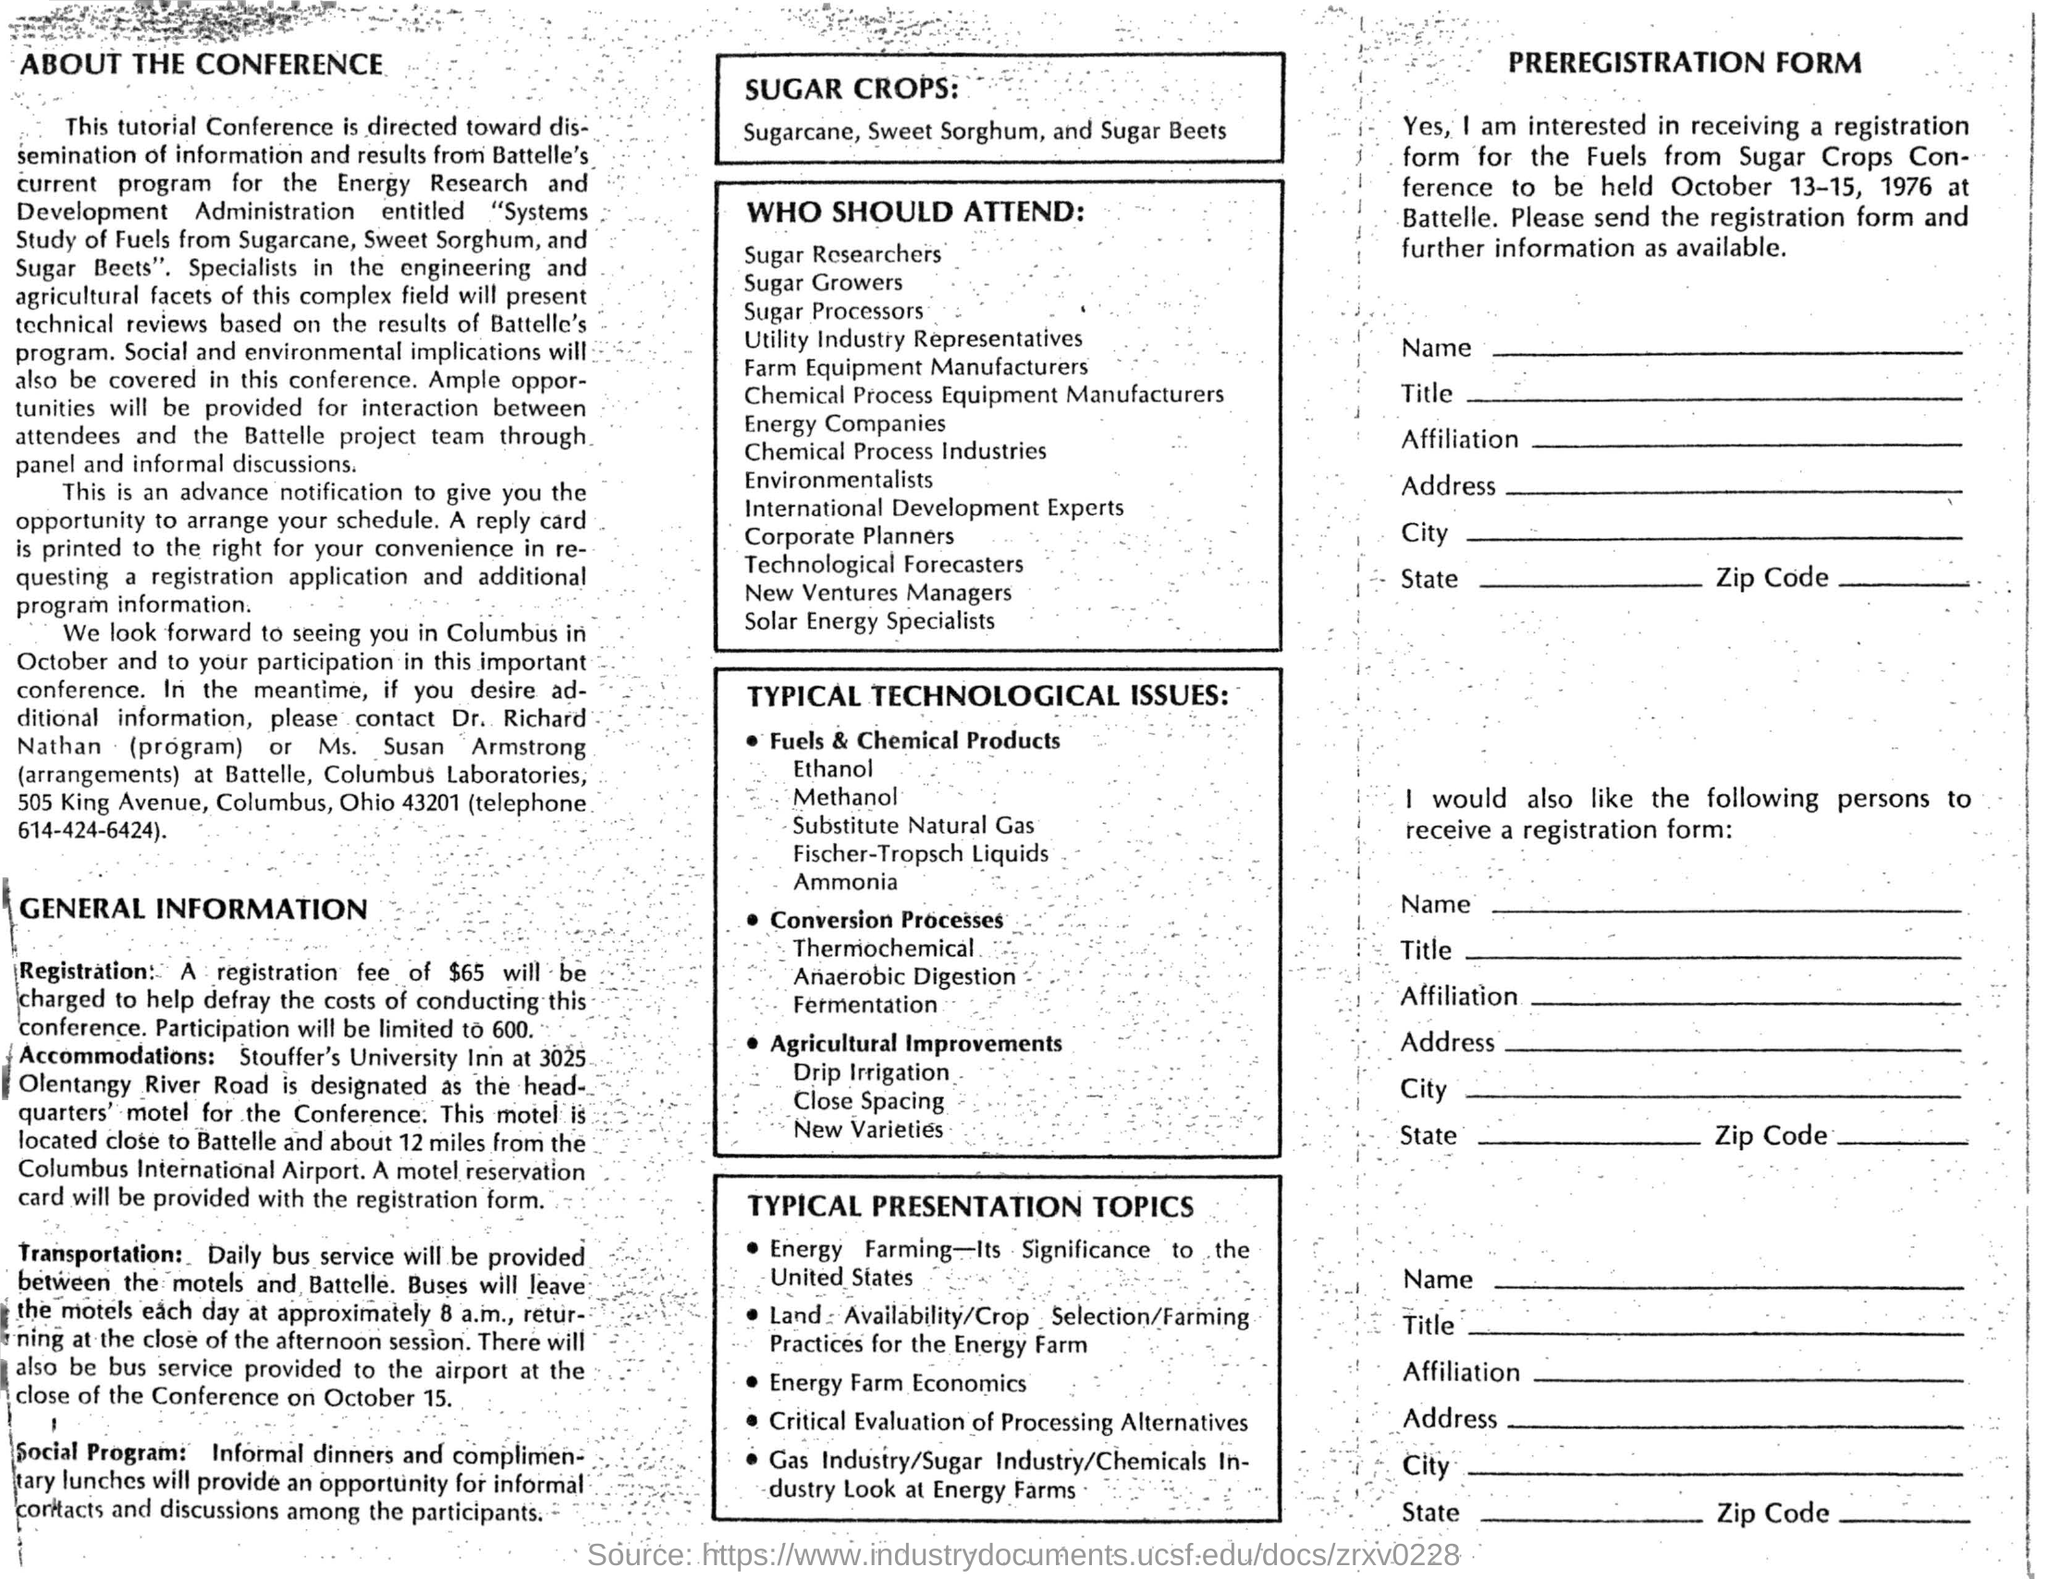What is the registration fee?
Your answer should be compact. $65. Where are the accommodations provided?
Give a very brief answer. Stouffer's University Inn. Which inn is designated as the headquarter's motel for the conference?
Keep it short and to the point. Stouffer's University Inn at 3025 Olentangy River Road. When is the conference going to be held?
Your answer should be very brief. October 13-15, 1976. Who to contact to get additional information on program?
Your answer should be very brief. Dr Richard Nathan. List sugar crops mentioned in the conference document.
Your answer should be compact. Sugarcane, sweet sorghum, and sugar beets. 